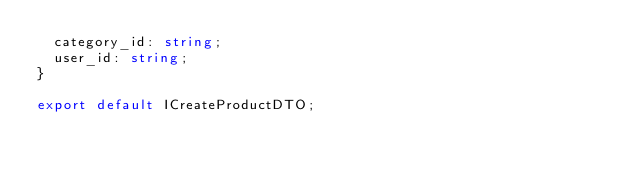Convert code to text. <code><loc_0><loc_0><loc_500><loc_500><_TypeScript_>  category_id: string;
  user_id: string;
}

export default ICreateProductDTO;
</code> 